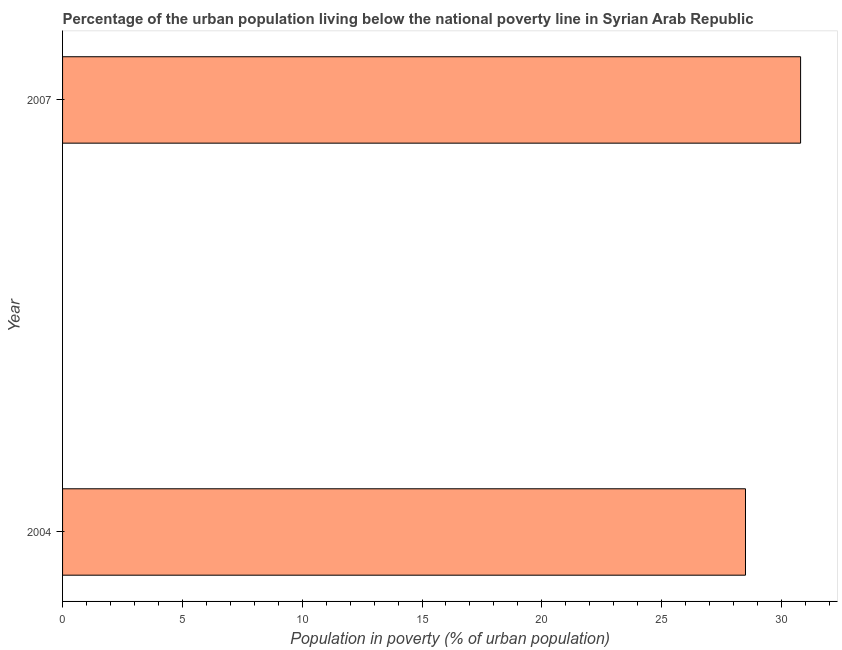What is the title of the graph?
Your answer should be very brief. Percentage of the urban population living below the national poverty line in Syrian Arab Republic. What is the label or title of the X-axis?
Your answer should be very brief. Population in poverty (% of urban population). Across all years, what is the maximum percentage of urban population living below poverty line?
Offer a terse response. 30.8. In which year was the percentage of urban population living below poverty line maximum?
Offer a very short reply. 2007. What is the sum of the percentage of urban population living below poverty line?
Offer a very short reply. 59.3. What is the difference between the percentage of urban population living below poverty line in 2004 and 2007?
Your response must be concise. -2.3. What is the average percentage of urban population living below poverty line per year?
Offer a very short reply. 29.65. What is the median percentage of urban population living below poverty line?
Your answer should be compact. 29.65. Do a majority of the years between 2007 and 2004 (inclusive) have percentage of urban population living below poverty line greater than 21 %?
Your answer should be very brief. No. What is the ratio of the percentage of urban population living below poverty line in 2004 to that in 2007?
Provide a succinct answer. 0.93. In how many years, is the percentage of urban population living below poverty line greater than the average percentage of urban population living below poverty line taken over all years?
Your response must be concise. 1. How many bars are there?
Your response must be concise. 2. Are all the bars in the graph horizontal?
Your answer should be very brief. Yes. Are the values on the major ticks of X-axis written in scientific E-notation?
Ensure brevity in your answer.  No. What is the Population in poverty (% of urban population) in 2004?
Give a very brief answer. 28.5. What is the Population in poverty (% of urban population) of 2007?
Ensure brevity in your answer.  30.8. What is the difference between the Population in poverty (% of urban population) in 2004 and 2007?
Your answer should be compact. -2.3. What is the ratio of the Population in poverty (% of urban population) in 2004 to that in 2007?
Provide a short and direct response. 0.93. 